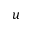<formula> <loc_0><loc_0><loc_500><loc_500>u</formula> 